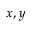<formula> <loc_0><loc_0><loc_500><loc_500>x , y</formula> 